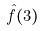Convert formula to latex. <formula><loc_0><loc_0><loc_500><loc_500>\hat { f } ( 3 )</formula> 